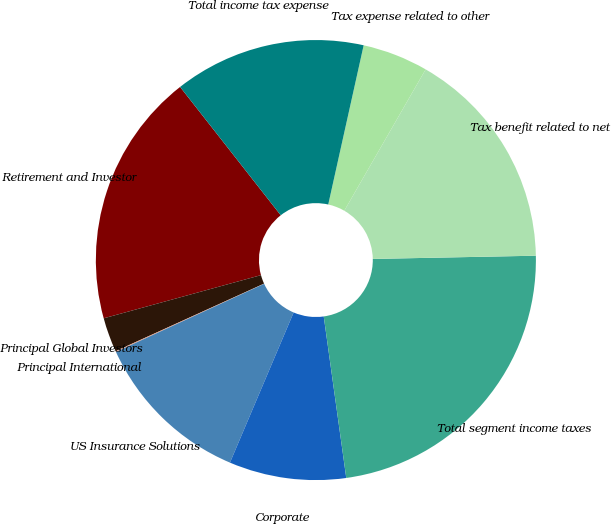Convert chart to OTSL. <chart><loc_0><loc_0><loc_500><loc_500><pie_chart><fcel>Retirement and Investor<fcel>Principal Global Investors<fcel>Principal International<fcel>US Insurance Solutions<fcel>Corporate<fcel>Total segment income taxes<fcel>Tax benefit related to net<fcel>Tax expense related to other<fcel>Total income tax expense<nl><fcel>18.68%<fcel>2.53%<fcel>0.06%<fcel>11.76%<fcel>8.59%<fcel>23.11%<fcel>16.37%<fcel>4.83%<fcel>14.07%<nl></chart> 